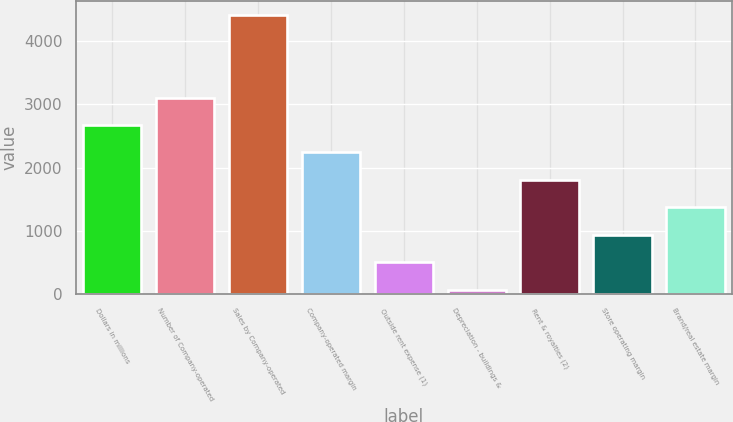Convert chart to OTSL. <chart><loc_0><loc_0><loc_500><loc_500><bar_chart><fcel>Dollars in millions<fcel>Number of Company-operated<fcel>Sales by Company-operated<fcel>Company-operated margin<fcel>Outside rent expense (1)<fcel>Depreciation - buildings &<fcel>Rent & royalties (2)<fcel>Store operating margin<fcel>Brand/real estate margin<nl><fcel>2675.6<fcel>3109.2<fcel>4410<fcel>2242<fcel>507.6<fcel>74<fcel>1808.4<fcel>941.2<fcel>1374.8<nl></chart> 